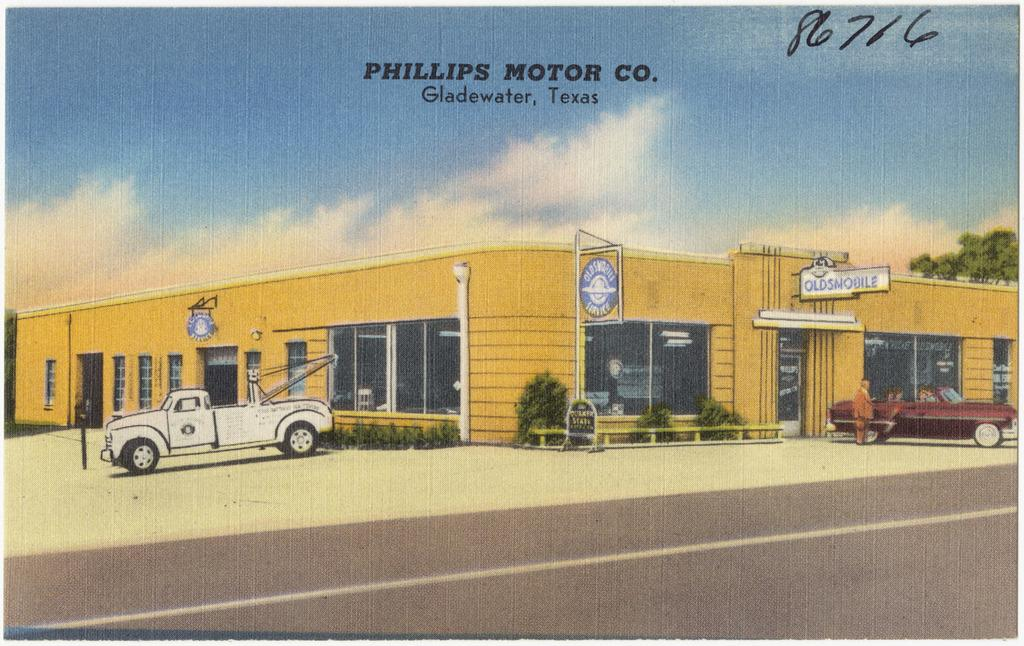What is the main subject of the image? The main subject of the image is a portrait of a building. What else can be seen in front of the building? There are two trucks in front of the building. Are there any other elements visible in the image besides the building and trucks? Yes, there are plants visible in the image. Can you tell me where the kitten is playing in the image? There is no kitten present in the image. What type of art is displayed on the building's facade in the image? The provided facts do not mention any art on the building's facade, so we cannot answer this question. 